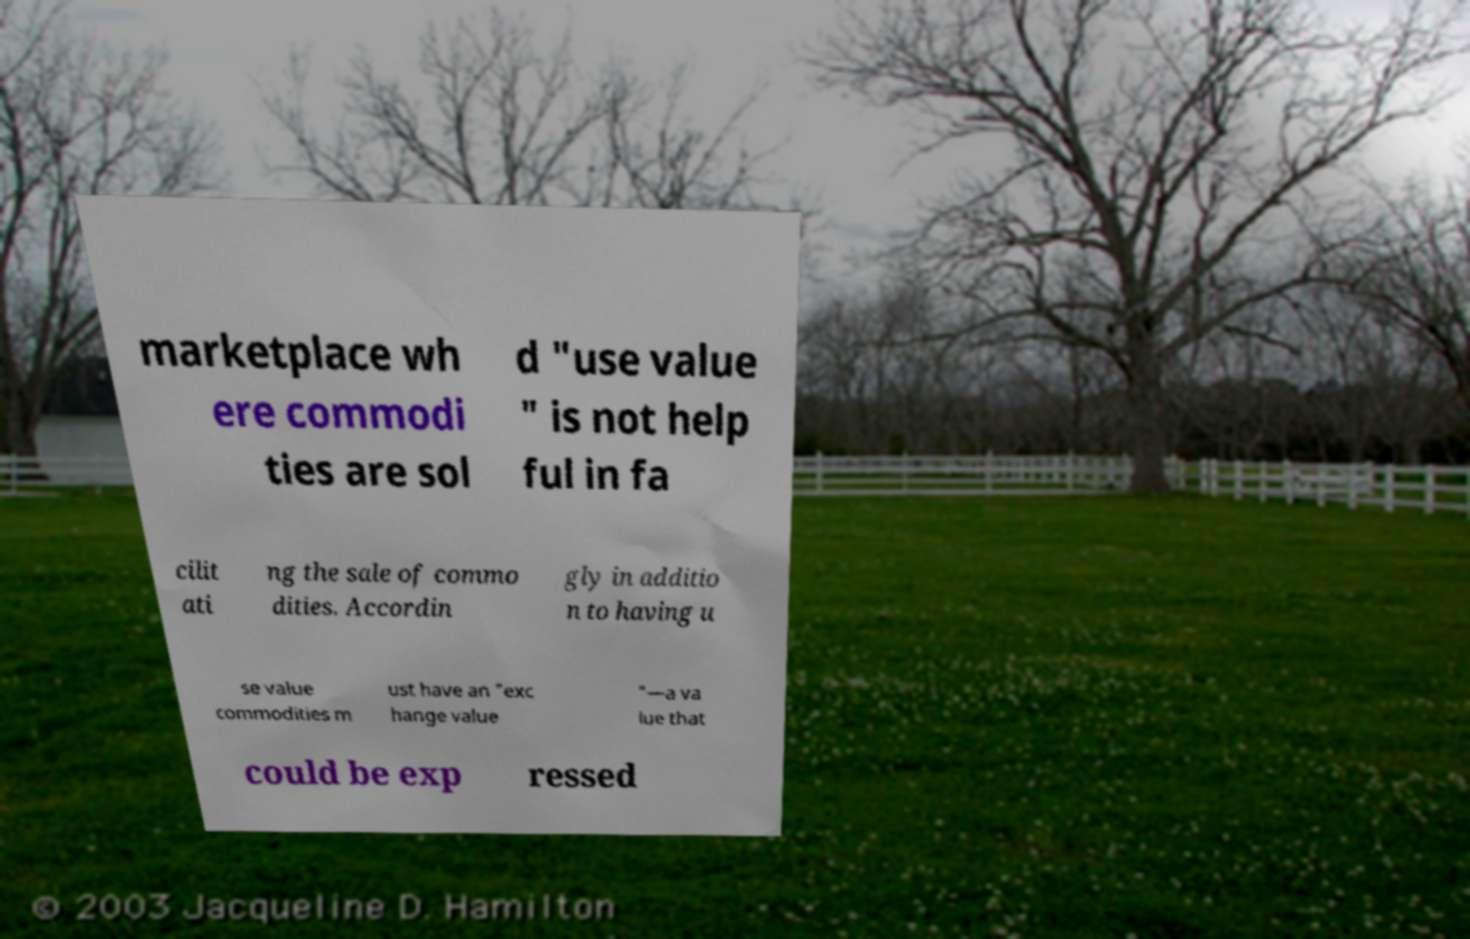Please read and relay the text visible in this image. What does it say? marketplace wh ere commodi ties are sol d "use value " is not help ful in fa cilit ati ng the sale of commo dities. Accordin gly in additio n to having u se value commodities m ust have an "exc hange value "—a va lue that could be exp ressed 